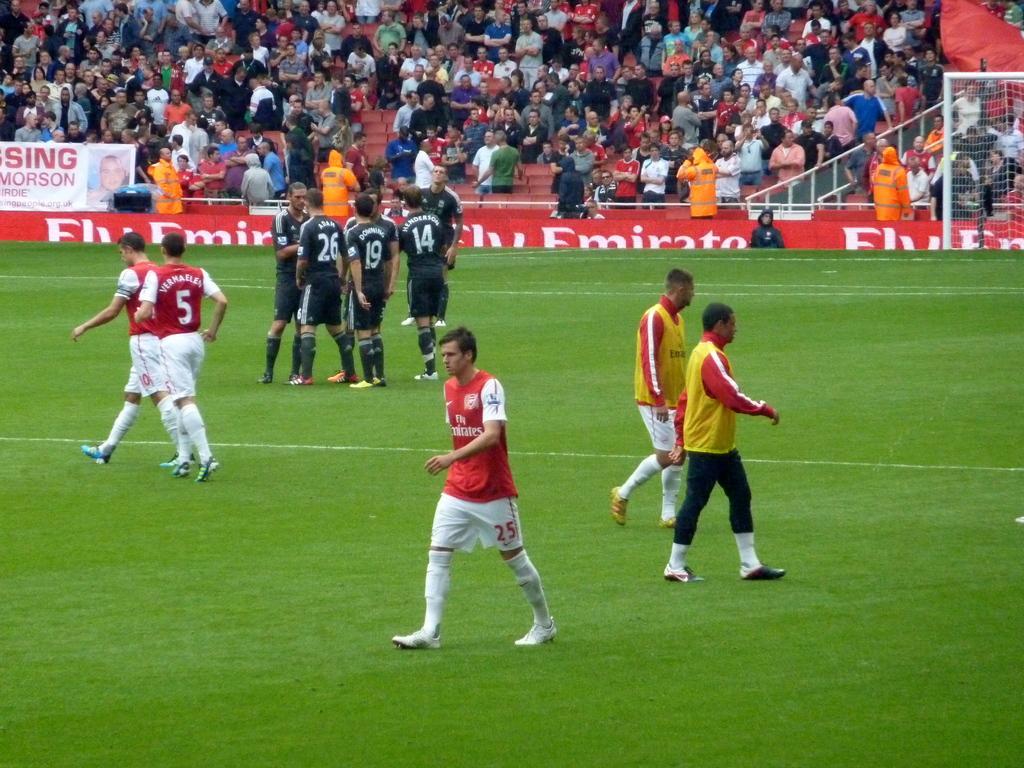Please provide a concise description of this image. In this image we can see people, grass, banners, mesh, and other objects. In the background we can see group of people. 